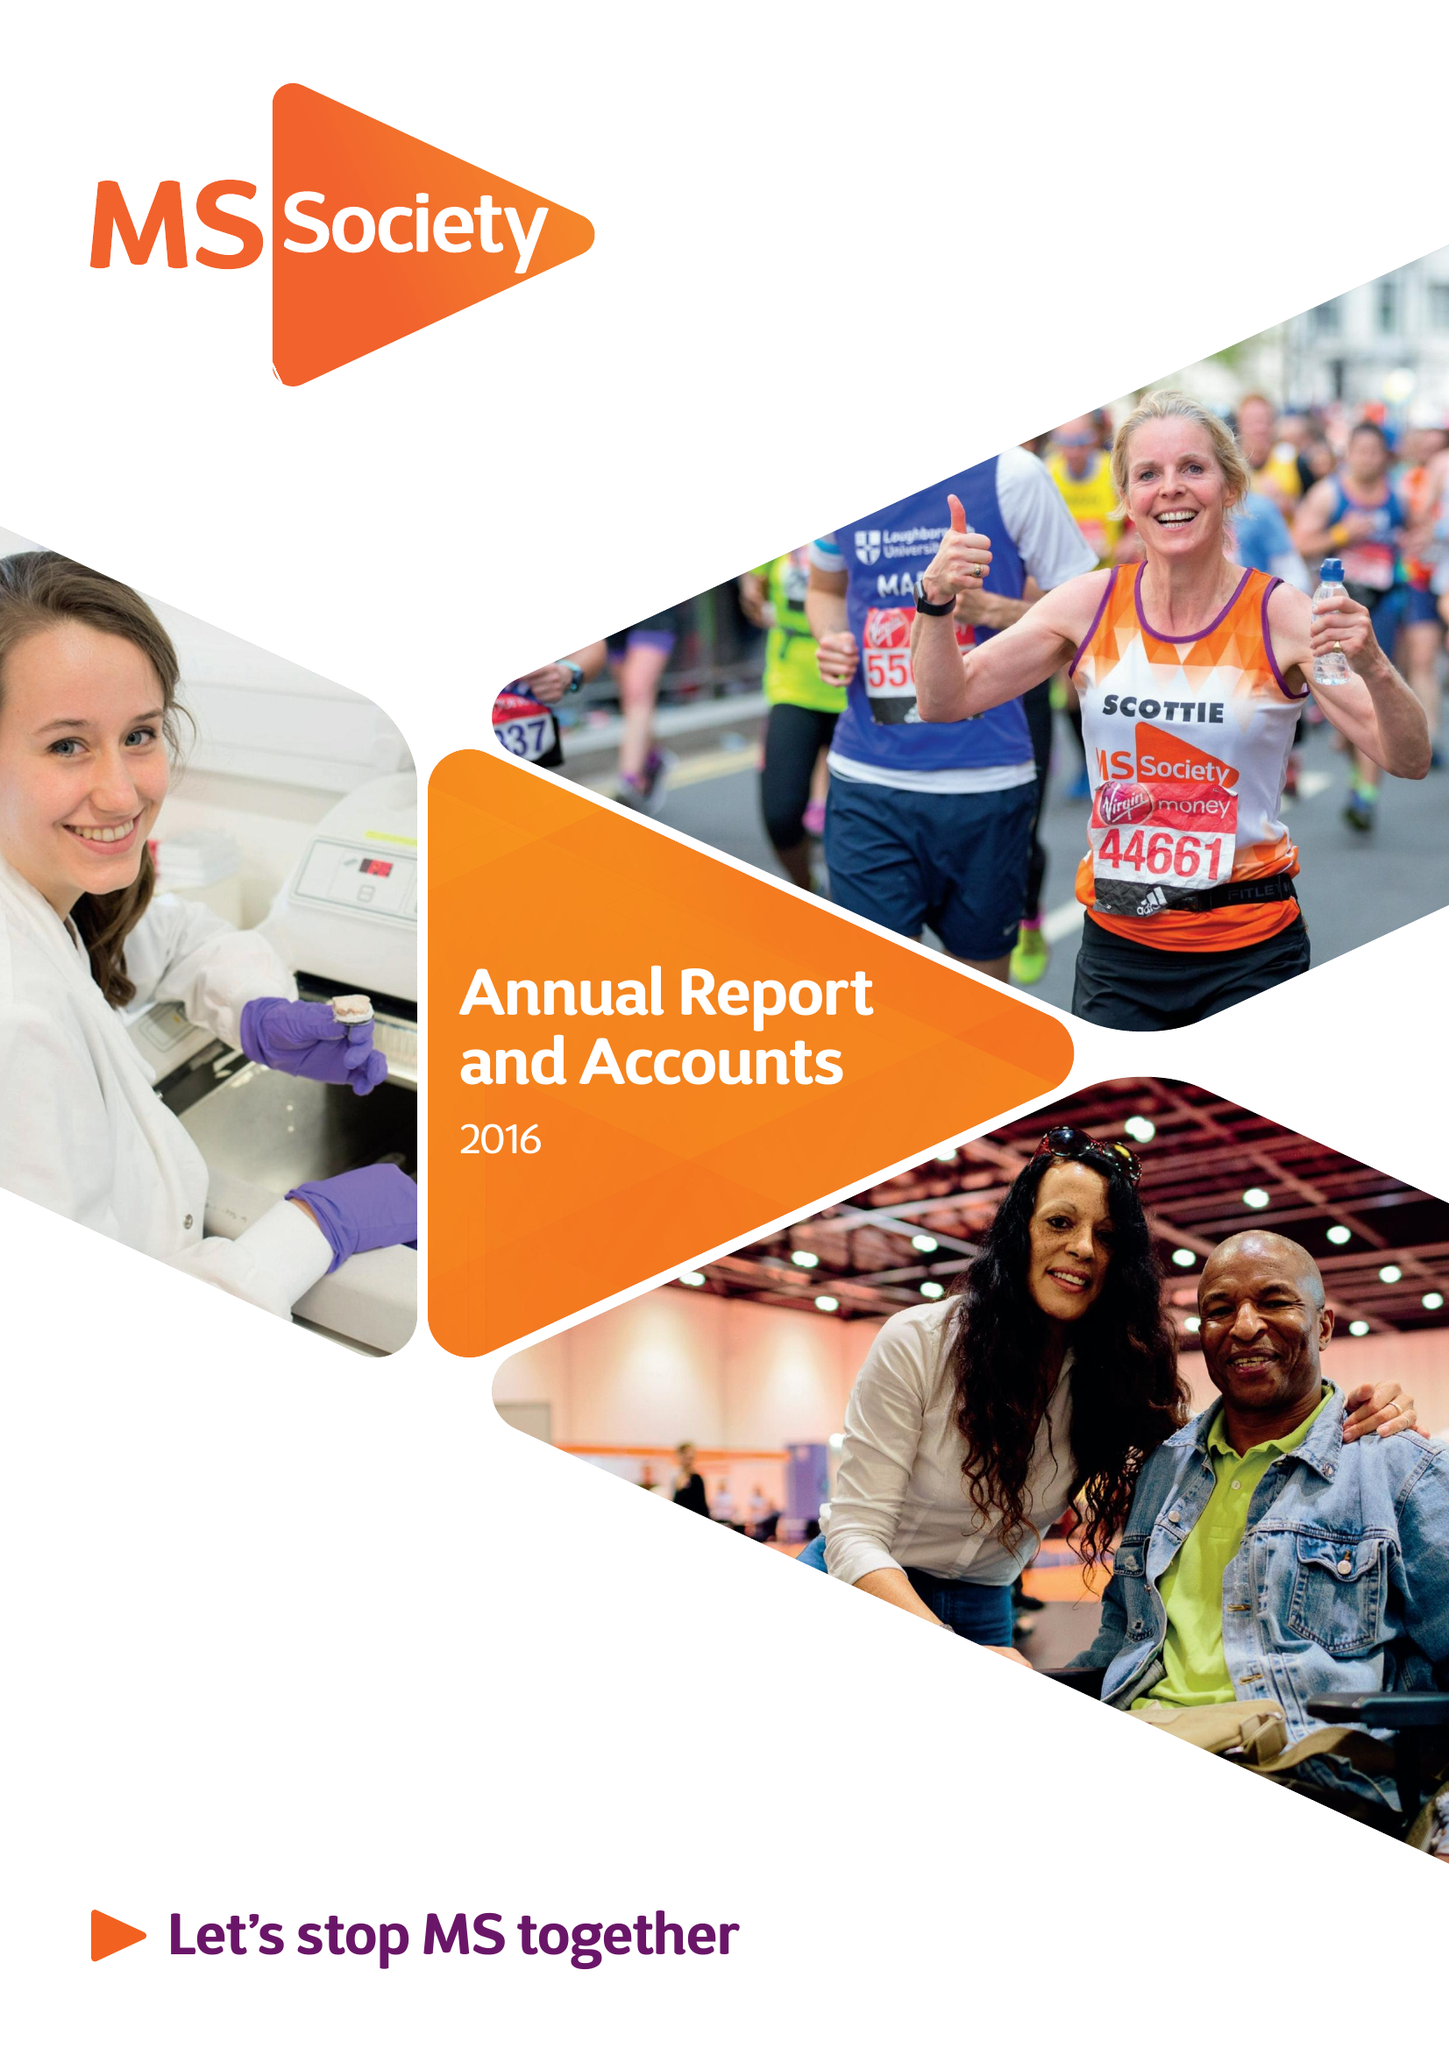What is the value for the address__postcode?
Answer the question using a single word or phrase. NW2 6ND 